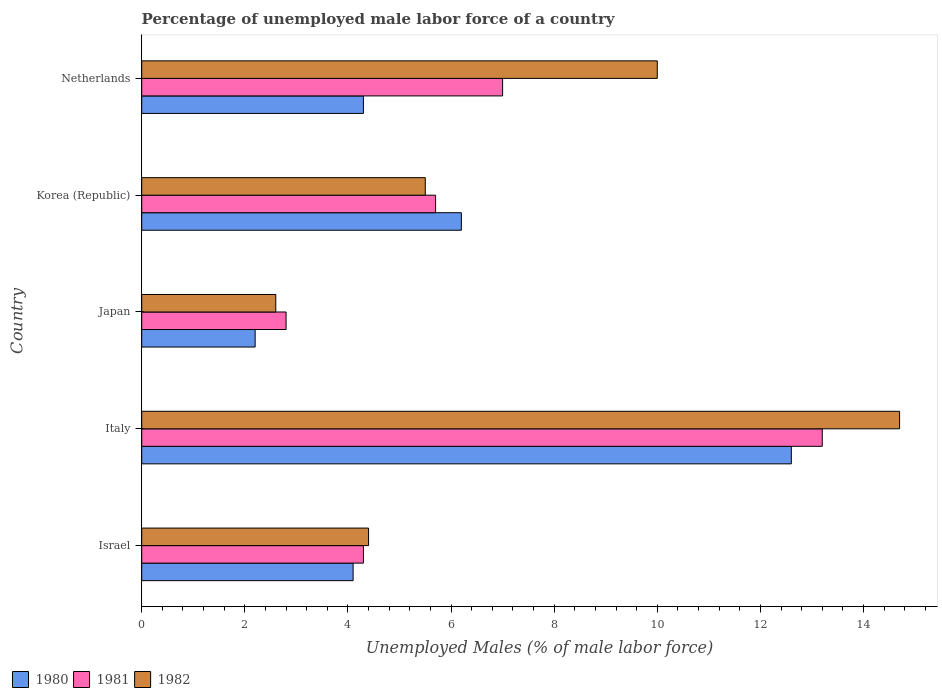How many different coloured bars are there?
Keep it short and to the point. 3. Are the number of bars per tick equal to the number of legend labels?
Provide a succinct answer. Yes. How many bars are there on the 2nd tick from the top?
Ensure brevity in your answer.  3. What is the percentage of unemployed male labor force in 1980 in Italy?
Give a very brief answer. 12.6. Across all countries, what is the maximum percentage of unemployed male labor force in 1980?
Offer a terse response. 12.6. Across all countries, what is the minimum percentage of unemployed male labor force in 1982?
Ensure brevity in your answer.  2.6. In which country was the percentage of unemployed male labor force in 1980 maximum?
Make the answer very short. Italy. What is the total percentage of unemployed male labor force in 1982 in the graph?
Make the answer very short. 37.2. What is the difference between the percentage of unemployed male labor force in 1980 in Italy and that in Netherlands?
Give a very brief answer. 8.3. What is the difference between the percentage of unemployed male labor force in 1981 in Israel and the percentage of unemployed male labor force in 1982 in Netherlands?
Offer a terse response. -5.7. What is the average percentage of unemployed male labor force in 1981 per country?
Your response must be concise. 6.6. What is the difference between the percentage of unemployed male labor force in 1981 and percentage of unemployed male labor force in 1982 in Israel?
Ensure brevity in your answer.  -0.1. In how many countries, is the percentage of unemployed male labor force in 1981 greater than 3.2 %?
Your answer should be compact. 4. What is the ratio of the percentage of unemployed male labor force in 1981 in Korea (Republic) to that in Netherlands?
Give a very brief answer. 0.81. Is the difference between the percentage of unemployed male labor force in 1981 in Israel and Japan greater than the difference between the percentage of unemployed male labor force in 1982 in Israel and Japan?
Keep it short and to the point. No. What is the difference between the highest and the second highest percentage of unemployed male labor force in 1981?
Your answer should be very brief. 6.2. What is the difference between the highest and the lowest percentage of unemployed male labor force in 1982?
Offer a terse response. 12.1. In how many countries, is the percentage of unemployed male labor force in 1982 greater than the average percentage of unemployed male labor force in 1982 taken over all countries?
Offer a very short reply. 2. What does the 1st bar from the bottom in Japan represents?
Offer a very short reply. 1980. What is the difference between two consecutive major ticks on the X-axis?
Your response must be concise. 2. Are the values on the major ticks of X-axis written in scientific E-notation?
Keep it short and to the point. No. Does the graph contain any zero values?
Offer a terse response. No. How are the legend labels stacked?
Make the answer very short. Horizontal. What is the title of the graph?
Offer a terse response. Percentage of unemployed male labor force of a country. Does "2011" appear as one of the legend labels in the graph?
Provide a short and direct response. No. What is the label or title of the X-axis?
Your response must be concise. Unemployed Males (% of male labor force). What is the Unemployed Males (% of male labor force) in 1980 in Israel?
Keep it short and to the point. 4.1. What is the Unemployed Males (% of male labor force) of 1981 in Israel?
Offer a very short reply. 4.3. What is the Unemployed Males (% of male labor force) in 1982 in Israel?
Ensure brevity in your answer.  4.4. What is the Unemployed Males (% of male labor force) of 1980 in Italy?
Give a very brief answer. 12.6. What is the Unemployed Males (% of male labor force) of 1981 in Italy?
Offer a very short reply. 13.2. What is the Unemployed Males (% of male labor force) of 1982 in Italy?
Give a very brief answer. 14.7. What is the Unemployed Males (% of male labor force) of 1980 in Japan?
Your answer should be compact. 2.2. What is the Unemployed Males (% of male labor force) of 1981 in Japan?
Offer a terse response. 2.8. What is the Unemployed Males (% of male labor force) of 1982 in Japan?
Provide a short and direct response. 2.6. What is the Unemployed Males (% of male labor force) in 1980 in Korea (Republic)?
Make the answer very short. 6.2. What is the Unemployed Males (% of male labor force) in 1981 in Korea (Republic)?
Give a very brief answer. 5.7. What is the Unemployed Males (% of male labor force) in 1982 in Korea (Republic)?
Provide a succinct answer. 5.5. What is the Unemployed Males (% of male labor force) in 1980 in Netherlands?
Your answer should be compact. 4.3. What is the Unemployed Males (% of male labor force) in 1981 in Netherlands?
Ensure brevity in your answer.  7. What is the Unemployed Males (% of male labor force) in 1982 in Netherlands?
Offer a very short reply. 10. Across all countries, what is the maximum Unemployed Males (% of male labor force) of 1980?
Make the answer very short. 12.6. Across all countries, what is the maximum Unemployed Males (% of male labor force) of 1981?
Your response must be concise. 13.2. Across all countries, what is the maximum Unemployed Males (% of male labor force) of 1982?
Ensure brevity in your answer.  14.7. Across all countries, what is the minimum Unemployed Males (% of male labor force) in 1980?
Make the answer very short. 2.2. Across all countries, what is the minimum Unemployed Males (% of male labor force) in 1981?
Your response must be concise. 2.8. Across all countries, what is the minimum Unemployed Males (% of male labor force) in 1982?
Offer a very short reply. 2.6. What is the total Unemployed Males (% of male labor force) of 1980 in the graph?
Provide a short and direct response. 29.4. What is the total Unemployed Males (% of male labor force) in 1982 in the graph?
Keep it short and to the point. 37.2. What is the difference between the Unemployed Males (% of male labor force) in 1980 in Israel and that in Italy?
Offer a terse response. -8.5. What is the difference between the Unemployed Males (% of male labor force) in 1981 in Israel and that in Italy?
Ensure brevity in your answer.  -8.9. What is the difference between the Unemployed Males (% of male labor force) of 1980 in Israel and that in Japan?
Your response must be concise. 1.9. What is the difference between the Unemployed Males (% of male labor force) in 1982 in Israel and that in Japan?
Your answer should be compact. 1.8. What is the difference between the Unemployed Males (% of male labor force) of 1981 in Italy and that in Japan?
Ensure brevity in your answer.  10.4. What is the difference between the Unemployed Males (% of male labor force) in 1982 in Italy and that in Japan?
Offer a very short reply. 12.1. What is the difference between the Unemployed Males (% of male labor force) in 1981 in Italy and that in Korea (Republic)?
Your answer should be very brief. 7.5. What is the difference between the Unemployed Males (% of male labor force) of 1980 in Italy and that in Netherlands?
Offer a very short reply. 8.3. What is the difference between the Unemployed Males (% of male labor force) in 1980 in Japan and that in Korea (Republic)?
Give a very brief answer. -4. What is the difference between the Unemployed Males (% of male labor force) in 1981 in Japan and that in Korea (Republic)?
Offer a very short reply. -2.9. What is the difference between the Unemployed Males (% of male labor force) of 1982 in Japan and that in Korea (Republic)?
Your answer should be compact. -2.9. What is the difference between the Unemployed Males (% of male labor force) of 1980 in Japan and that in Netherlands?
Provide a short and direct response. -2.1. What is the difference between the Unemployed Males (% of male labor force) in 1981 in Japan and that in Netherlands?
Your answer should be very brief. -4.2. What is the difference between the Unemployed Males (% of male labor force) in 1981 in Korea (Republic) and that in Netherlands?
Ensure brevity in your answer.  -1.3. What is the difference between the Unemployed Males (% of male labor force) in 1980 in Israel and the Unemployed Males (% of male labor force) in 1981 in Italy?
Give a very brief answer. -9.1. What is the difference between the Unemployed Males (% of male labor force) in 1981 in Israel and the Unemployed Males (% of male labor force) in 1982 in Italy?
Offer a terse response. -10.4. What is the difference between the Unemployed Males (% of male labor force) of 1980 in Israel and the Unemployed Males (% of male labor force) of 1982 in Japan?
Provide a short and direct response. 1.5. What is the difference between the Unemployed Males (% of male labor force) in 1981 in Israel and the Unemployed Males (% of male labor force) in 1982 in Korea (Republic)?
Your answer should be compact. -1.2. What is the difference between the Unemployed Males (% of male labor force) of 1980 in Israel and the Unemployed Males (% of male labor force) of 1981 in Netherlands?
Offer a terse response. -2.9. What is the difference between the Unemployed Males (% of male labor force) in 1980 in Israel and the Unemployed Males (% of male labor force) in 1982 in Netherlands?
Make the answer very short. -5.9. What is the difference between the Unemployed Males (% of male labor force) of 1981 in Israel and the Unemployed Males (% of male labor force) of 1982 in Netherlands?
Provide a succinct answer. -5.7. What is the difference between the Unemployed Males (% of male labor force) in 1980 in Italy and the Unemployed Males (% of male labor force) in 1981 in Japan?
Your answer should be very brief. 9.8. What is the difference between the Unemployed Males (% of male labor force) of 1981 in Italy and the Unemployed Males (% of male labor force) of 1982 in Japan?
Keep it short and to the point. 10.6. What is the difference between the Unemployed Males (% of male labor force) of 1980 in Italy and the Unemployed Males (% of male labor force) of 1981 in Netherlands?
Ensure brevity in your answer.  5.6. What is the difference between the Unemployed Males (% of male labor force) of 1980 in Japan and the Unemployed Males (% of male labor force) of 1981 in Korea (Republic)?
Offer a very short reply. -3.5. What is the difference between the Unemployed Males (% of male labor force) of 1980 in Japan and the Unemployed Males (% of male labor force) of 1982 in Netherlands?
Your response must be concise. -7.8. What is the difference between the Unemployed Males (% of male labor force) of 1981 in Korea (Republic) and the Unemployed Males (% of male labor force) of 1982 in Netherlands?
Make the answer very short. -4.3. What is the average Unemployed Males (% of male labor force) of 1980 per country?
Give a very brief answer. 5.88. What is the average Unemployed Males (% of male labor force) in 1982 per country?
Offer a very short reply. 7.44. What is the difference between the Unemployed Males (% of male labor force) in 1980 and Unemployed Males (% of male labor force) in 1981 in Israel?
Offer a terse response. -0.2. What is the difference between the Unemployed Males (% of male labor force) of 1980 and Unemployed Males (% of male labor force) of 1982 in Israel?
Keep it short and to the point. -0.3. What is the difference between the Unemployed Males (% of male labor force) in 1981 and Unemployed Males (% of male labor force) in 1982 in Israel?
Offer a very short reply. -0.1. What is the difference between the Unemployed Males (% of male labor force) of 1980 and Unemployed Males (% of male labor force) of 1981 in Italy?
Provide a succinct answer. -0.6. What is the difference between the Unemployed Males (% of male labor force) in 1980 and Unemployed Males (% of male labor force) in 1982 in Italy?
Your answer should be very brief. -2.1. What is the difference between the Unemployed Males (% of male labor force) of 1980 and Unemployed Males (% of male labor force) of 1981 in Korea (Republic)?
Give a very brief answer. 0.5. What is the difference between the Unemployed Males (% of male labor force) in 1981 and Unemployed Males (% of male labor force) in 1982 in Korea (Republic)?
Ensure brevity in your answer.  0.2. What is the difference between the Unemployed Males (% of male labor force) in 1980 and Unemployed Males (% of male labor force) in 1981 in Netherlands?
Provide a succinct answer. -2.7. What is the difference between the Unemployed Males (% of male labor force) in 1980 and Unemployed Males (% of male labor force) in 1982 in Netherlands?
Provide a succinct answer. -5.7. What is the ratio of the Unemployed Males (% of male labor force) in 1980 in Israel to that in Italy?
Provide a short and direct response. 0.33. What is the ratio of the Unemployed Males (% of male labor force) of 1981 in Israel to that in Italy?
Your answer should be compact. 0.33. What is the ratio of the Unemployed Males (% of male labor force) in 1982 in Israel to that in Italy?
Your response must be concise. 0.3. What is the ratio of the Unemployed Males (% of male labor force) of 1980 in Israel to that in Japan?
Provide a succinct answer. 1.86. What is the ratio of the Unemployed Males (% of male labor force) of 1981 in Israel to that in Japan?
Your answer should be compact. 1.54. What is the ratio of the Unemployed Males (% of male labor force) in 1982 in Israel to that in Japan?
Your answer should be compact. 1.69. What is the ratio of the Unemployed Males (% of male labor force) in 1980 in Israel to that in Korea (Republic)?
Your response must be concise. 0.66. What is the ratio of the Unemployed Males (% of male labor force) in 1981 in Israel to that in Korea (Republic)?
Provide a short and direct response. 0.75. What is the ratio of the Unemployed Males (% of male labor force) in 1980 in Israel to that in Netherlands?
Keep it short and to the point. 0.95. What is the ratio of the Unemployed Males (% of male labor force) in 1981 in Israel to that in Netherlands?
Give a very brief answer. 0.61. What is the ratio of the Unemployed Males (% of male labor force) in 1982 in Israel to that in Netherlands?
Give a very brief answer. 0.44. What is the ratio of the Unemployed Males (% of male labor force) of 1980 in Italy to that in Japan?
Ensure brevity in your answer.  5.73. What is the ratio of the Unemployed Males (% of male labor force) in 1981 in Italy to that in Japan?
Your answer should be very brief. 4.71. What is the ratio of the Unemployed Males (% of male labor force) of 1982 in Italy to that in Japan?
Your response must be concise. 5.65. What is the ratio of the Unemployed Males (% of male labor force) in 1980 in Italy to that in Korea (Republic)?
Your answer should be compact. 2.03. What is the ratio of the Unemployed Males (% of male labor force) of 1981 in Italy to that in Korea (Republic)?
Give a very brief answer. 2.32. What is the ratio of the Unemployed Males (% of male labor force) of 1982 in Italy to that in Korea (Republic)?
Your answer should be compact. 2.67. What is the ratio of the Unemployed Males (% of male labor force) of 1980 in Italy to that in Netherlands?
Your answer should be very brief. 2.93. What is the ratio of the Unemployed Males (% of male labor force) in 1981 in Italy to that in Netherlands?
Your answer should be compact. 1.89. What is the ratio of the Unemployed Males (% of male labor force) of 1982 in Italy to that in Netherlands?
Offer a terse response. 1.47. What is the ratio of the Unemployed Males (% of male labor force) of 1980 in Japan to that in Korea (Republic)?
Ensure brevity in your answer.  0.35. What is the ratio of the Unemployed Males (% of male labor force) in 1981 in Japan to that in Korea (Republic)?
Provide a succinct answer. 0.49. What is the ratio of the Unemployed Males (% of male labor force) of 1982 in Japan to that in Korea (Republic)?
Your answer should be compact. 0.47. What is the ratio of the Unemployed Males (% of male labor force) in 1980 in Japan to that in Netherlands?
Your answer should be compact. 0.51. What is the ratio of the Unemployed Males (% of male labor force) of 1982 in Japan to that in Netherlands?
Keep it short and to the point. 0.26. What is the ratio of the Unemployed Males (% of male labor force) of 1980 in Korea (Republic) to that in Netherlands?
Keep it short and to the point. 1.44. What is the ratio of the Unemployed Males (% of male labor force) of 1981 in Korea (Republic) to that in Netherlands?
Your answer should be compact. 0.81. What is the ratio of the Unemployed Males (% of male labor force) in 1982 in Korea (Republic) to that in Netherlands?
Keep it short and to the point. 0.55. What is the difference between the highest and the lowest Unemployed Males (% of male labor force) in 1980?
Your response must be concise. 10.4. What is the difference between the highest and the lowest Unemployed Males (% of male labor force) of 1982?
Your answer should be compact. 12.1. 